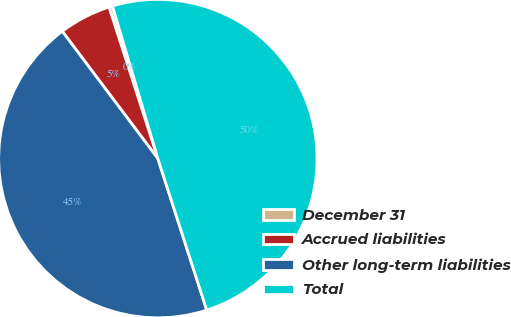Convert chart. <chart><loc_0><loc_0><loc_500><loc_500><pie_chart><fcel>December 31<fcel>Accrued liabilities<fcel>Other long-term liabilities<fcel>Total<nl><fcel>0.36%<fcel>5.29%<fcel>44.71%<fcel>49.64%<nl></chart> 